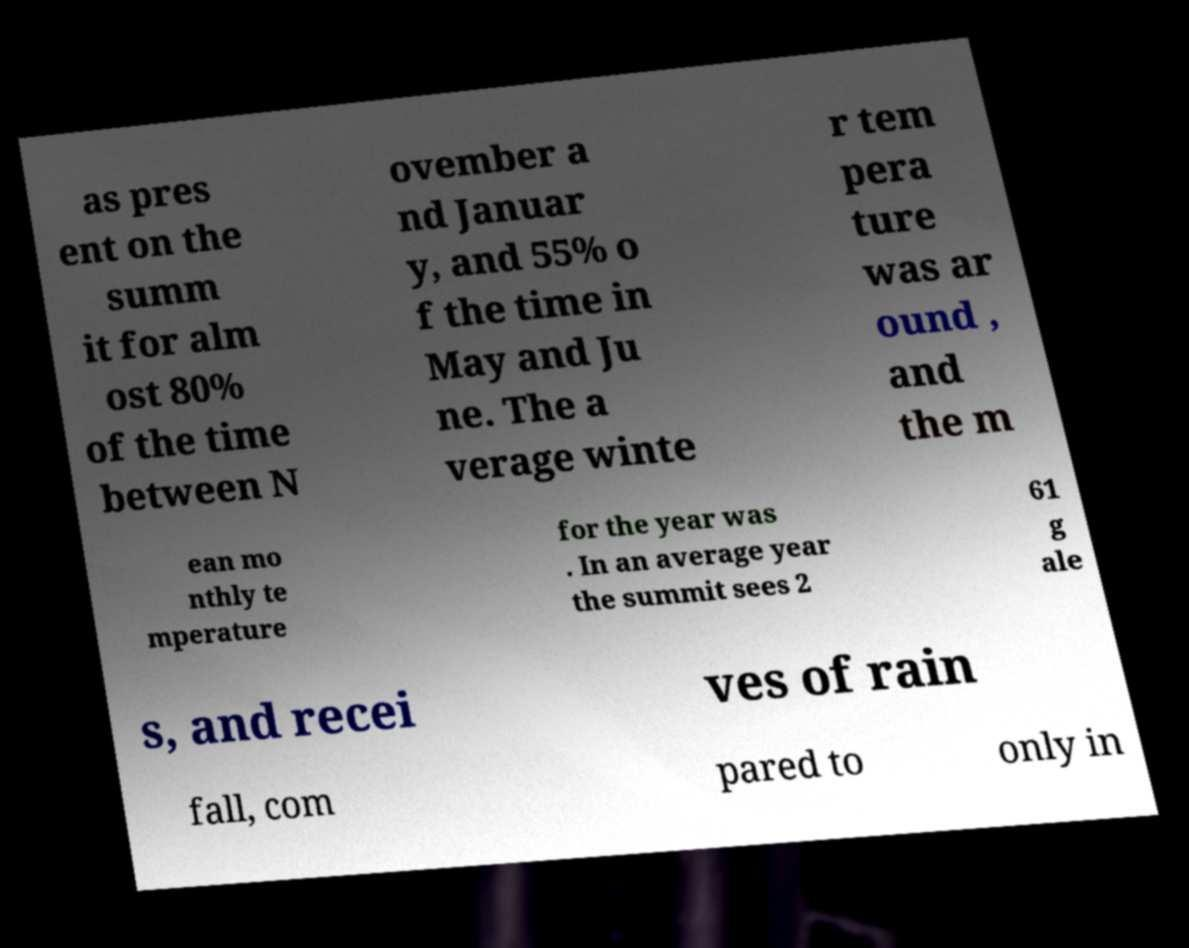Can you accurately transcribe the text from the provided image for me? as pres ent on the summ it for alm ost 80% of the time between N ovember a nd Januar y, and 55% o f the time in May and Ju ne. The a verage winte r tem pera ture was ar ound , and the m ean mo nthly te mperature for the year was . In an average year the summit sees 2 61 g ale s, and recei ves of rain fall, com pared to only in 